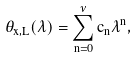<formula> <loc_0><loc_0><loc_500><loc_500>\theta _ { x , L } ( \lambda ) = \sum _ { n = 0 } ^ { \nu } c _ { n } \lambda ^ { n } ,</formula> 